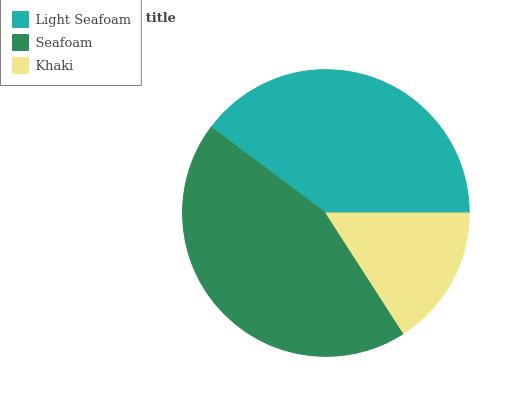Is Khaki the minimum?
Answer yes or no. Yes. Is Seafoam the maximum?
Answer yes or no. Yes. Is Seafoam the minimum?
Answer yes or no. No. Is Khaki the maximum?
Answer yes or no. No. Is Seafoam greater than Khaki?
Answer yes or no. Yes. Is Khaki less than Seafoam?
Answer yes or no. Yes. Is Khaki greater than Seafoam?
Answer yes or no. No. Is Seafoam less than Khaki?
Answer yes or no. No. Is Light Seafoam the high median?
Answer yes or no. Yes. Is Light Seafoam the low median?
Answer yes or no. Yes. Is Khaki the high median?
Answer yes or no. No. Is Seafoam the low median?
Answer yes or no. No. 